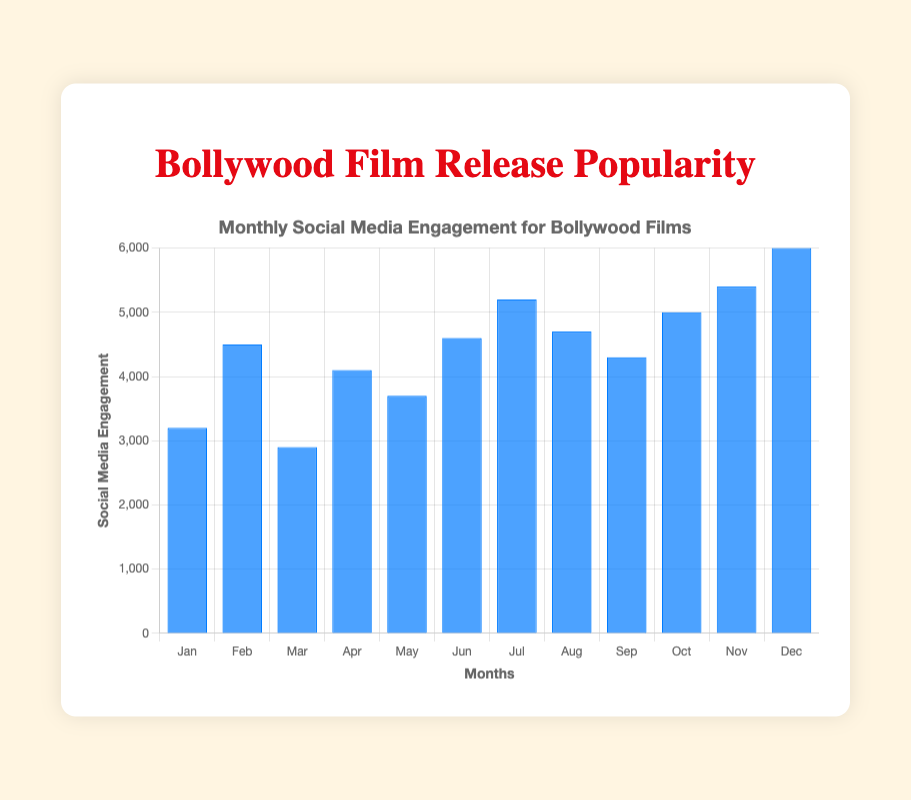What is the month with the highest social media engagement? The bar for December is the tallest among all months, indicating the highest social media engagement.
Answer: December How much higher is the social media engagement in December than in January? The social media engagement in December is 6000 and in January it is 3200. So, 6000 - 3200 = 2800.
Answer: 2800 Which two consecutive months have the closest social media engagement? By checking the difference in engagement between each pair of consecutive months, August (4700) and September (4300) have the smallest difference: 4700 - 4300 = 400.
Answer: August and September What is the average social media engagement for the first six months of the year? Sum the engagements from January to June: 3200 + 4500 + 2900 + 4100 + 3700 + 4600 = 23000. Then divide by 6: 23000 / 6 = 3833.33.
Answer: 3833.33 In which month did social media engagement see the largest increase compared to the previous month? Calculate the differences month by month: 
February - January: 4500 - 3200 = 1300 
March - February: 2900 - 4500 = -1600 
April - March: 4100 - 2900 = 1200 
May - April: 3700 - 4100 = -400 
June - May: 4600 - 3700 = 900 
July - June: 5200 - 4600 = 600 
August - July: 4700 - 5200 = -500 
September - August: 4300 - 4700 = -400 
October - September: 5000 - 4300 = 700 
November - October: 5400 - 5000 = 400 
December - November: 6000 - 5400 = 600 
The largest increase (+1300) is between January and February.
Answer: February Which months had social media engagement more than 5000? The bars for November and December are above the 5000 mark.
Answer: November and December Compare the social media engagement in July and August, which month had more and by how much? July had 5200 and August had 4700. The difference is 5200 - 4700 = 500.
Answer: July by 500 What is the total social media engagement for the months which have more than 4000 engagements? Sum the engagements for February (4500), April (4100), June (4600), July (5200), August (4700), September (4300), October (5000), November (5400), and December (6000): 4500 + 4100 + 4600 + 5200 + 4700 + 4300 + 5000 + 5400 + 6000 = 43800.
Answer: 43800 What percentage of the total annual social media engagement does December account for? First, find the total social media engagement for the year: 3200 + 4500 + 2900 + 4100 + 3700 + 4600 + 5200 + 4700 + 4300 + 5000 + 5400 + 6000 = 53600. December is 6000. Percentage is (6000 / 53600) * 100 = 11.19%.
Answer: 11.19% 